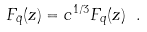Convert formula to latex. <formula><loc_0><loc_0><loc_500><loc_500>F _ { \bar { q } } ( z ) = c ^ { 1 / 3 } F _ { q } ( z ) \ .</formula> 